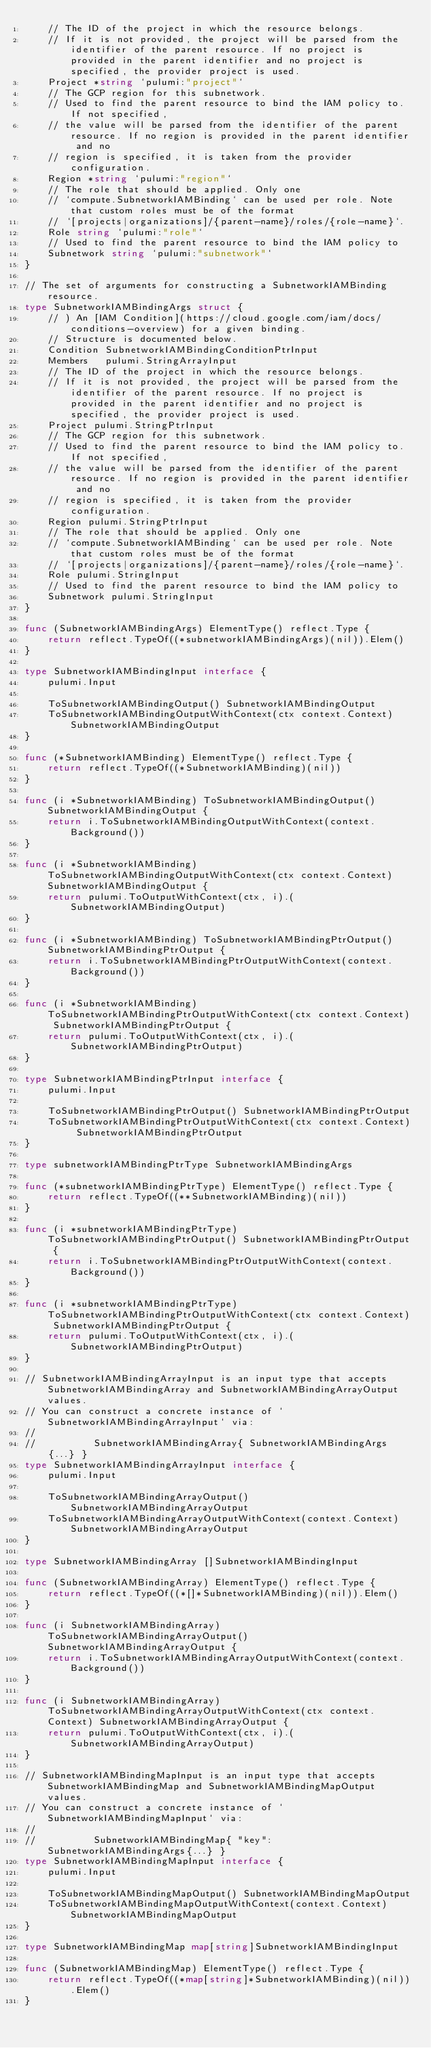<code> <loc_0><loc_0><loc_500><loc_500><_Go_>	// The ID of the project in which the resource belongs.
	// If it is not provided, the project will be parsed from the identifier of the parent resource. If no project is provided in the parent identifier and no project is specified, the provider project is used.
	Project *string `pulumi:"project"`
	// The GCP region for this subnetwork.
	// Used to find the parent resource to bind the IAM policy to. If not specified,
	// the value will be parsed from the identifier of the parent resource. If no region is provided in the parent identifier and no
	// region is specified, it is taken from the provider configuration.
	Region *string `pulumi:"region"`
	// The role that should be applied. Only one
	// `compute.SubnetworkIAMBinding` can be used per role. Note that custom roles must be of the format
	// `[projects|organizations]/{parent-name}/roles/{role-name}`.
	Role string `pulumi:"role"`
	// Used to find the parent resource to bind the IAM policy to
	Subnetwork string `pulumi:"subnetwork"`
}

// The set of arguments for constructing a SubnetworkIAMBinding resource.
type SubnetworkIAMBindingArgs struct {
	// ) An [IAM Condition](https://cloud.google.com/iam/docs/conditions-overview) for a given binding.
	// Structure is documented below.
	Condition SubnetworkIAMBindingConditionPtrInput
	Members   pulumi.StringArrayInput
	// The ID of the project in which the resource belongs.
	// If it is not provided, the project will be parsed from the identifier of the parent resource. If no project is provided in the parent identifier and no project is specified, the provider project is used.
	Project pulumi.StringPtrInput
	// The GCP region for this subnetwork.
	// Used to find the parent resource to bind the IAM policy to. If not specified,
	// the value will be parsed from the identifier of the parent resource. If no region is provided in the parent identifier and no
	// region is specified, it is taken from the provider configuration.
	Region pulumi.StringPtrInput
	// The role that should be applied. Only one
	// `compute.SubnetworkIAMBinding` can be used per role. Note that custom roles must be of the format
	// `[projects|organizations]/{parent-name}/roles/{role-name}`.
	Role pulumi.StringInput
	// Used to find the parent resource to bind the IAM policy to
	Subnetwork pulumi.StringInput
}

func (SubnetworkIAMBindingArgs) ElementType() reflect.Type {
	return reflect.TypeOf((*subnetworkIAMBindingArgs)(nil)).Elem()
}

type SubnetworkIAMBindingInput interface {
	pulumi.Input

	ToSubnetworkIAMBindingOutput() SubnetworkIAMBindingOutput
	ToSubnetworkIAMBindingOutputWithContext(ctx context.Context) SubnetworkIAMBindingOutput
}

func (*SubnetworkIAMBinding) ElementType() reflect.Type {
	return reflect.TypeOf((*SubnetworkIAMBinding)(nil))
}

func (i *SubnetworkIAMBinding) ToSubnetworkIAMBindingOutput() SubnetworkIAMBindingOutput {
	return i.ToSubnetworkIAMBindingOutputWithContext(context.Background())
}

func (i *SubnetworkIAMBinding) ToSubnetworkIAMBindingOutputWithContext(ctx context.Context) SubnetworkIAMBindingOutput {
	return pulumi.ToOutputWithContext(ctx, i).(SubnetworkIAMBindingOutput)
}

func (i *SubnetworkIAMBinding) ToSubnetworkIAMBindingPtrOutput() SubnetworkIAMBindingPtrOutput {
	return i.ToSubnetworkIAMBindingPtrOutputWithContext(context.Background())
}

func (i *SubnetworkIAMBinding) ToSubnetworkIAMBindingPtrOutputWithContext(ctx context.Context) SubnetworkIAMBindingPtrOutput {
	return pulumi.ToOutputWithContext(ctx, i).(SubnetworkIAMBindingPtrOutput)
}

type SubnetworkIAMBindingPtrInput interface {
	pulumi.Input

	ToSubnetworkIAMBindingPtrOutput() SubnetworkIAMBindingPtrOutput
	ToSubnetworkIAMBindingPtrOutputWithContext(ctx context.Context) SubnetworkIAMBindingPtrOutput
}

type subnetworkIAMBindingPtrType SubnetworkIAMBindingArgs

func (*subnetworkIAMBindingPtrType) ElementType() reflect.Type {
	return reflect.TypeOf((**SubnetworkIAMBinding)(nil))
}

func (i *subnetworkIAMBindingPtrType) ToSubnetworkIAMBindingPtrOutput() SubnetworkIAMBindingPtrOutput {
	return i.ToSubnetworkIAMBindingPtrOutputWithContext(context.Background())
}

func (i *subnetworkIAMBindingPtrType) ToSubnetworkIAMBindingPtrOutputWithContext(ctx context.Context) SubnetworkIAMBindingPtrOutput {
	return pulumi.ToOutputWithContext(ctx, i).(SubnetworkIAMBindingPtrOutput)
}

// SubnetworkIAMBindingArrayInput is an input type that accepts SubnetworkIAMBindingArray and SubnetworkIAMBindingArrayOutput values.
// You can construct a concrete instance of `SubnetworkIAMBindingArrayInput` via:
//
//          SubnetworkIAMBindingArray{ SubnetworkIAMBindingArgs{...} }
type SubnetworkIAMBindingArrayInput interface {
	pulumi.Input

	ToSubnetworkIAMBindingArrayOutput() SubnetworkIAMBindingArrayOutput
	ToSubnetworkIAMBindingArrayOutputWithContext(context.Context) SubnetworkIAMBindingArrayOutput
}

type SubnetworkIAMBindingArray []SubnetworkIAMBindingInput

func (SubnetworkIAMBindingArray) ElementType() reflect.Type {
	return reflect.TypeOf((*[]*SubnetworkIAMBinding)(nil)).Elem()
}

func (i SubnetworkIAMBindingArray) ToSubnetworkIAMBindingArrayOutput() SubnetworkIAMBindingArrayOutput {
	return i.ToSubnetworkIAMBindingArrayOutputWithContext(context.Background())
}

func (i SubnetworkIAMBindingArray) ToSubnetworkIAMBindingArrayOutputWithContext(ctx context.Context) SubnetworkIAMBindingArrayOutput {
	return pulumi.ToOutputWithContext(ctx, i).(SubnetworkIAMBindingArrayOutput)
}

// SubnetworkIAMBindingMapInput is an input type that accepts SubnetworkIAMBindingMap and SubnetworkIAMBindingMapOutput values.
// You can construct a concrete instance of `SubnetworkIAMBindingMapInput` via:
//
//          SubnetworkIAMBindingMap{ "key": SubnetworkIAMBindingArgs{...} }
type SubnetworkIAMBindingMapInput interface {
	pulumi.Input

	ToSubnetworkIAMBindingMapOutput() SubnetworkIAMBindingMapOutput
	ToSubnetworkIAMBindingMapOutputWithContext(context.Context) SubnetworkIAMBindingMapOutput
}

type SubnetworkIAMBindingMap map[string]SubnetworkIAMBindingInput

func (SubnetworkIAMBindingMap) ElementType() reflect.Type {
	return reflect.TypeOf((*map[string]*SubnetworkIAMBinding)(nil)).Elem()
}
</code> 